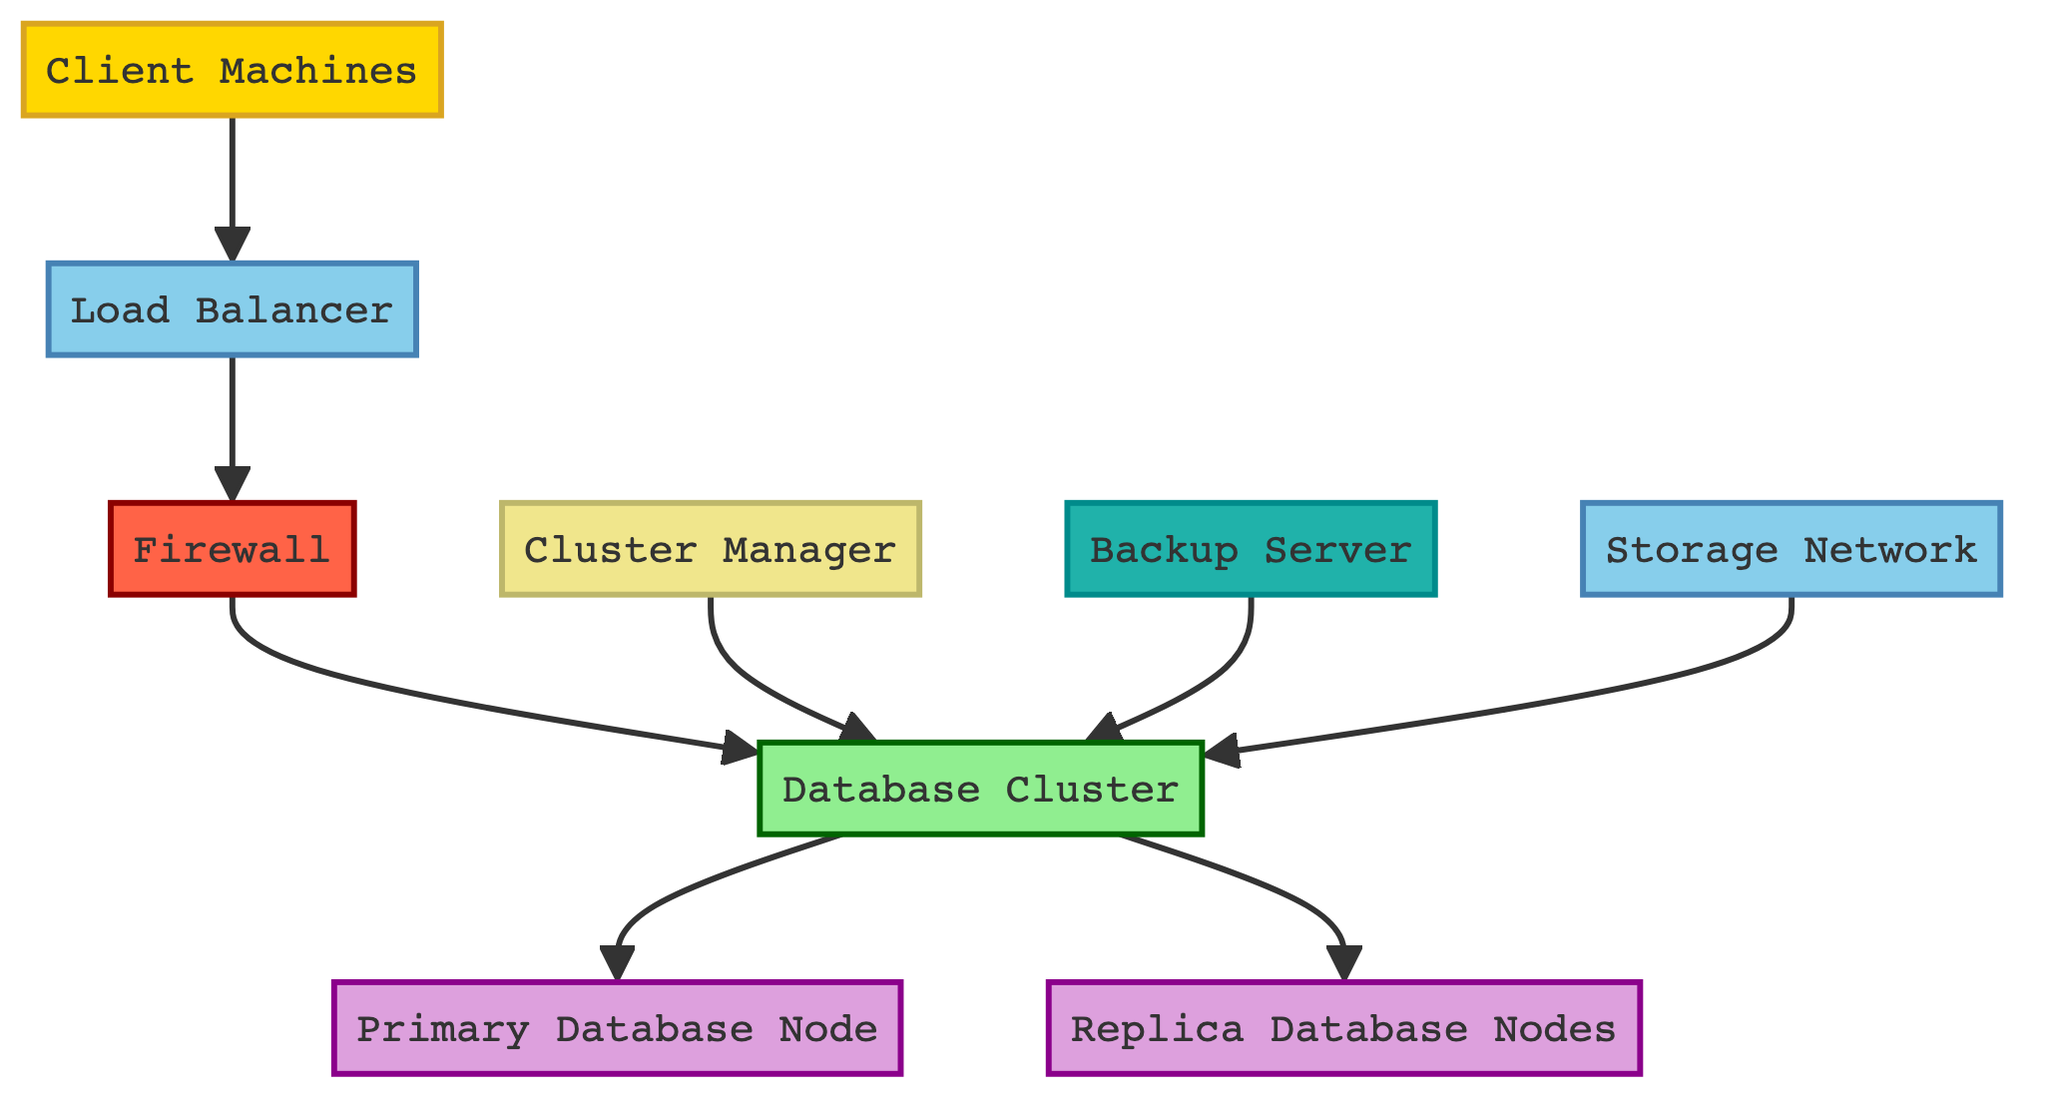What type of node is the Load Balancer? The Load Balancer is categorized as a network node according to the diagram classification. This can be seen by its color and label within the context of the diagram structure.
Answer: network How many compute nodes are in the Database Cluster? The Database Cluster comprises two distinct compute nodes: the Primary Database Node and the Replica Database Nodes. This count is derived by identifying the node types category and counting the labels for that specific type.
Answer: 2 What is the role of the Backup Server? The Backup Server's role is to periodically perform backups of the database cluster to ensure data recovery in case of failure. This was expressed in the descriptive content associated with that specific node in the diagram.
Answer: data recovery Which node connects directly to the Firewall? The Firewall is connected directly to the Database Cluster node, as shown in the directed flow of the diagram. Both the edges and nodes indicate this relationship visually.
Answer: Database Cluster What does the Cluster Manager manage? The Cluster Manager manages the operations of the Database Cluster, ensuring high availability and consistency across the database nodes. This role is outlined in the description related to the Cluster Manager node specifically.
Answer: database operations Which node handles all write operations? The Primary Database Node is responsible for handling all write operations within the cluster, as indicated in its description. Therefore, this node is designated as the main node for these activities.
Answer: Primary Database Node How is incoming traffic handled before reaching the Database Cluster? Incoming traffic is first directed to the Load Balancer, which then distributes those requests efficiently to different database nodes. This pathway indicates the processing flow of requests in the diagram.
Answer: Load Balancer What type of security measures are present in the diagram? The diagram includes a Firewall categorized as a security node that filters and monitors network traffic, indicating measures to secure the network against unauthorized access.
Answer: Firewall 